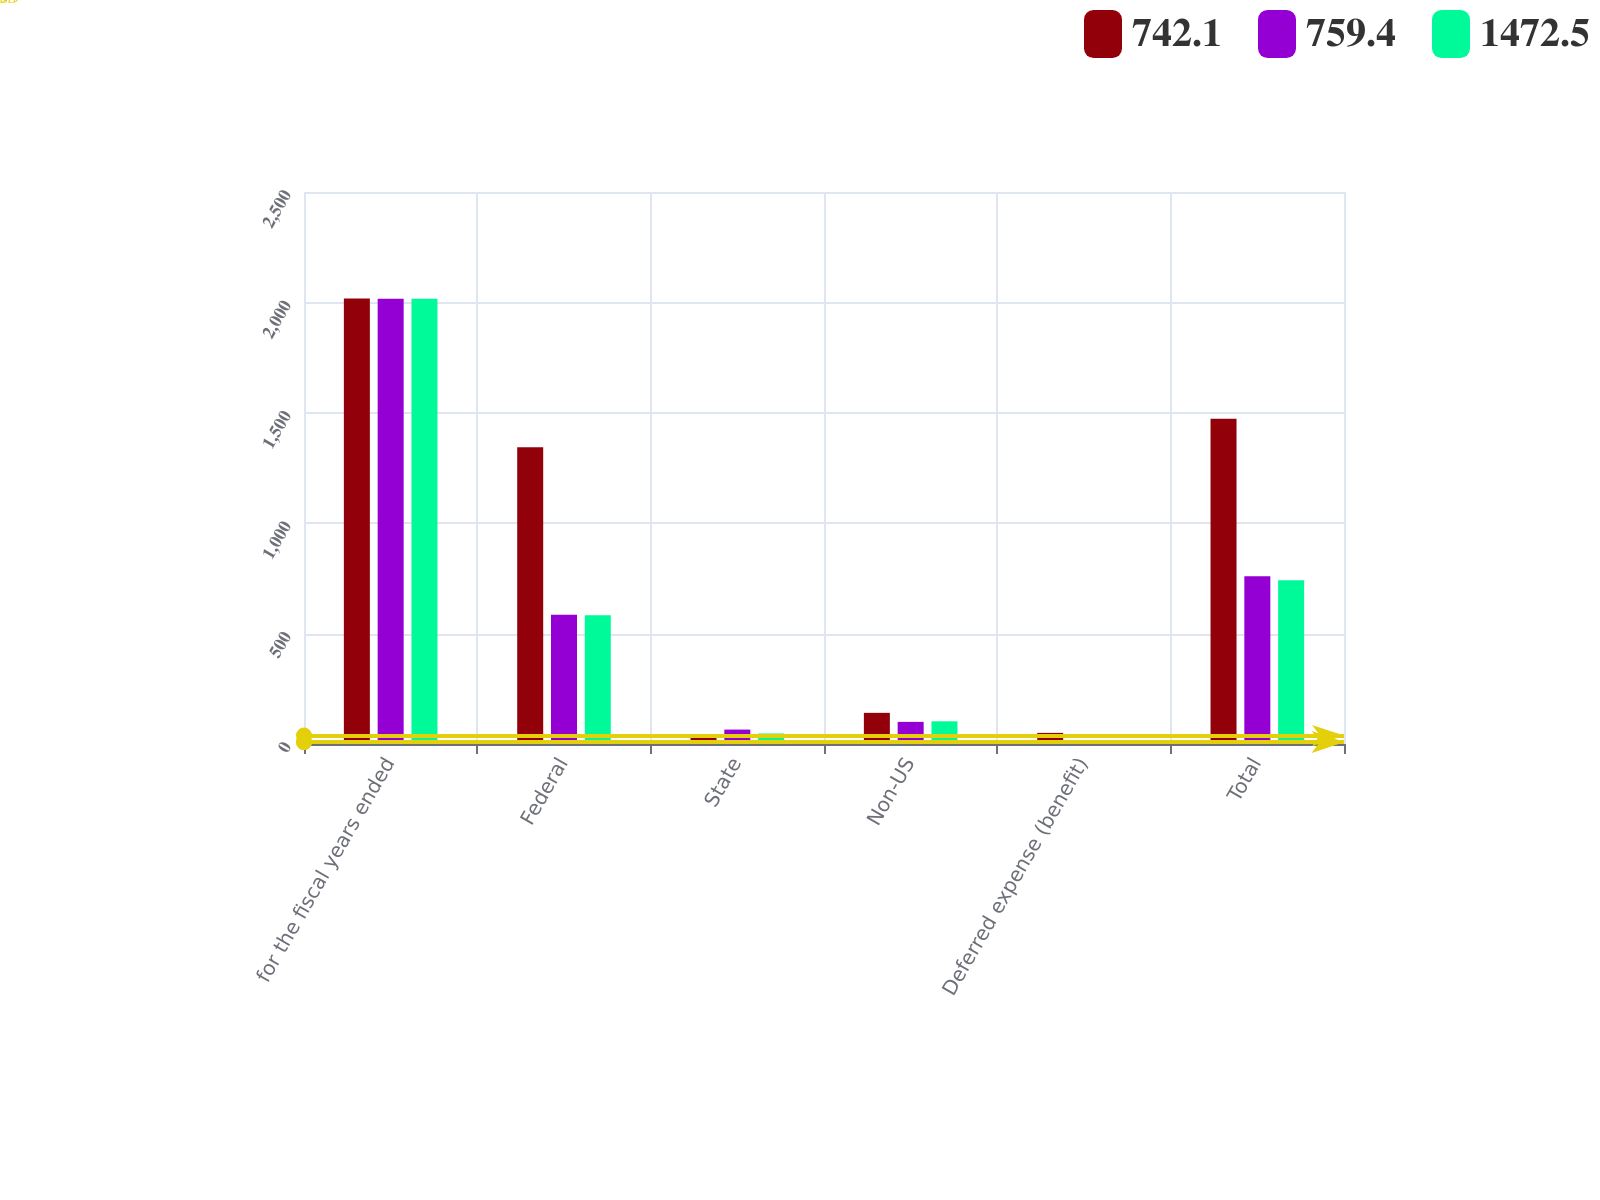<chart> <loc_0><loc_0><loc_500><loc_500><stacked_bar_chart><ecel><fcel>for the fiscal years ended<fcel>Federal<fcel>State<fcel>Non-US<fcel>Deferred expense (benefit)<fcel>Total<nl><fcel>742.1<fcel>2018<fcel>1343.7<fcel>38<fcel>141.1<fcel>50.3<fcel>1472.5<nl><fcel>759.4<fcel>2017<fcel>585<fcel>65.3<fcel>100.2<fcel>8.9<fcel>759.4<nl><fcel>1472.5<fcel>2016<fcel>582.8<fcel>47.5<fcel>102.8<fcel>9<fcel>742.1<nl></chart> 